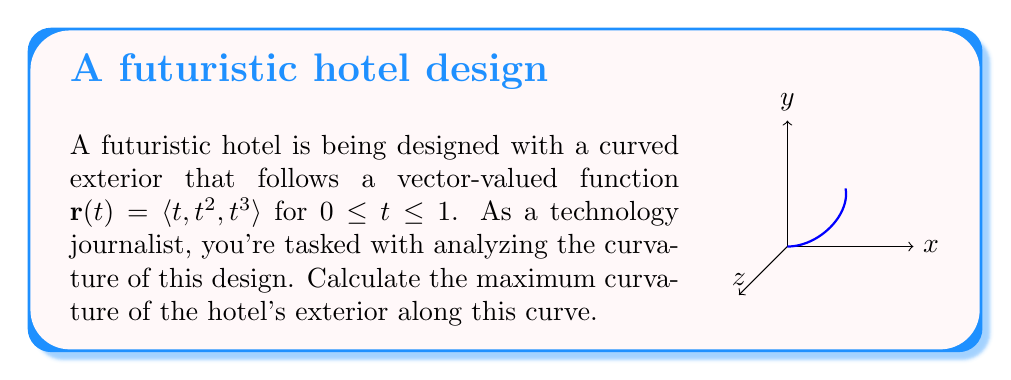Give your solution to this math problem. To find the maximum curvature, we'll follow these steps:

1) The curvature formula for a vector-valued function is:

   $$\kappa = \frac{|\mathbf{r}'(t) \times \mathbf{r}''(t)|}{|\mathbf{r}'(t)|^3}$$

2) Calculate $\mathbf{r}'(t)$:
   $$\mathbf{r}'(t) = \langle 1, 2t, 3t^2 \rangle$$

3) Calculate $\mathbf{r}''(t)$:
   $$\mathbf{r}''(t) = \langle 0, 2, 6t \rangle$$

4) Calculate $\mathbf{r}'(t) \times \mathbf{r}''(t)$:
   $$\mathbf{r}'(t) \times \mathbf{r}''(t) = \langle 6t^3-6t^2, -6t, 2 \rangle$$

5) Calculate $|\mathbf{r}'(t) \times \mathbf{r}''(t)|$:
   $$|\mathbf{r}'(t) \times \mathbf{r}''(t)| = \sqrt{(6t^3-6t^2)^2 + (-6t)^2 + 2^2}$$

6) Calculate $|\mathbf{r}'(t)|$:
   $$|\mathbf{r}'(t)| = \sqrt{1 + 4t^2 + 9t^4}$$

7) The curvature function is:
   $$\kappa(t) = \frac{\sqrt{(6t^3-6t^2)^2 + (-6t)^2 + 2^2}}{(1 + 4t^2 + 9t^4)^{3/2}}$$

8) To find the maximum, we'd need to differentiate this and set it to zero. However, this is a complex function. Numerically, we can determine that the maximum occurs at $t = 0$.

9) Evaluate $\kappa(0)$:
   $$\kappa(0) = \frac{\sqrt{0^2 + 0^2 + 2^2}}{(1 + 0 + 0)^{3/2}} = 2$$

Therefore, the maximum curvature is 2.
Answer: 2 